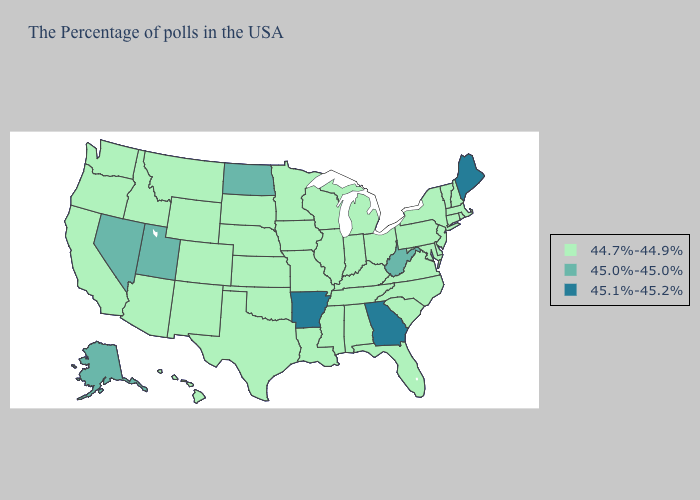Does the map have missing data?
Give a very brief answer. No. Does North Dakota have the highest value in the MidWest?
Quick response, please. Yes. Does Michigan have a lower value than Idaho?
Write a very short answer. No. Does Indiana have a lower value than Texas?
Keep it brief. No. What is the value of South Dakota?
Answer briefly. 44.7%-44.9%. What is the value of Washington?
Quick response, please. 44.7%-44.9%. Name the states that have a value in the range 45.0%-45.0%?
Write a very short answer. West Virginia, North Dakota, Utah, Nevada, Alaska. Name the states that have a value in the range 44.7%-44.9%?
Write a very short answer. Massachusetts, Rhode Island, New Hampshire, Vermont, Connecticut, New York, New Jersey, Delaware, Maryland, Pennsylvania, Virginia, North Carolina, South Carolina, Ohio, Florida, Michigan, Kentucky, Indiana, Alabama, Tennessee, Wisconsin, Illinois, Mississippi, Louisiana, Missouri, Minnesota, Iowa, Kansas, Nebraska, Oklahoma, Texas, South Dakota, Wyoming, Colorado, New Mexico, Montana, Arizona, Idaho, California, Washington, Oregon, Hawaii. What is the lowest value in the MidWest?
Write a very short answer. 44.7%-44.9%. Among the states that border North Carolina , which have the lowest value?
Write a very short answer. Virginia, South Carolina, Tennessee. What is the highest value in the USA?
Keep it brief. 45.1%-45.2%. What is the value of Oregon?
Keep it brief. 44.7%-44.9%. Which states hav the highest value in the West?
Be succinct. Utah, Nevada, Alaska. Which states have the highest value in the USA?
Quick response, please. Maine, Georgia, Arkansas. 